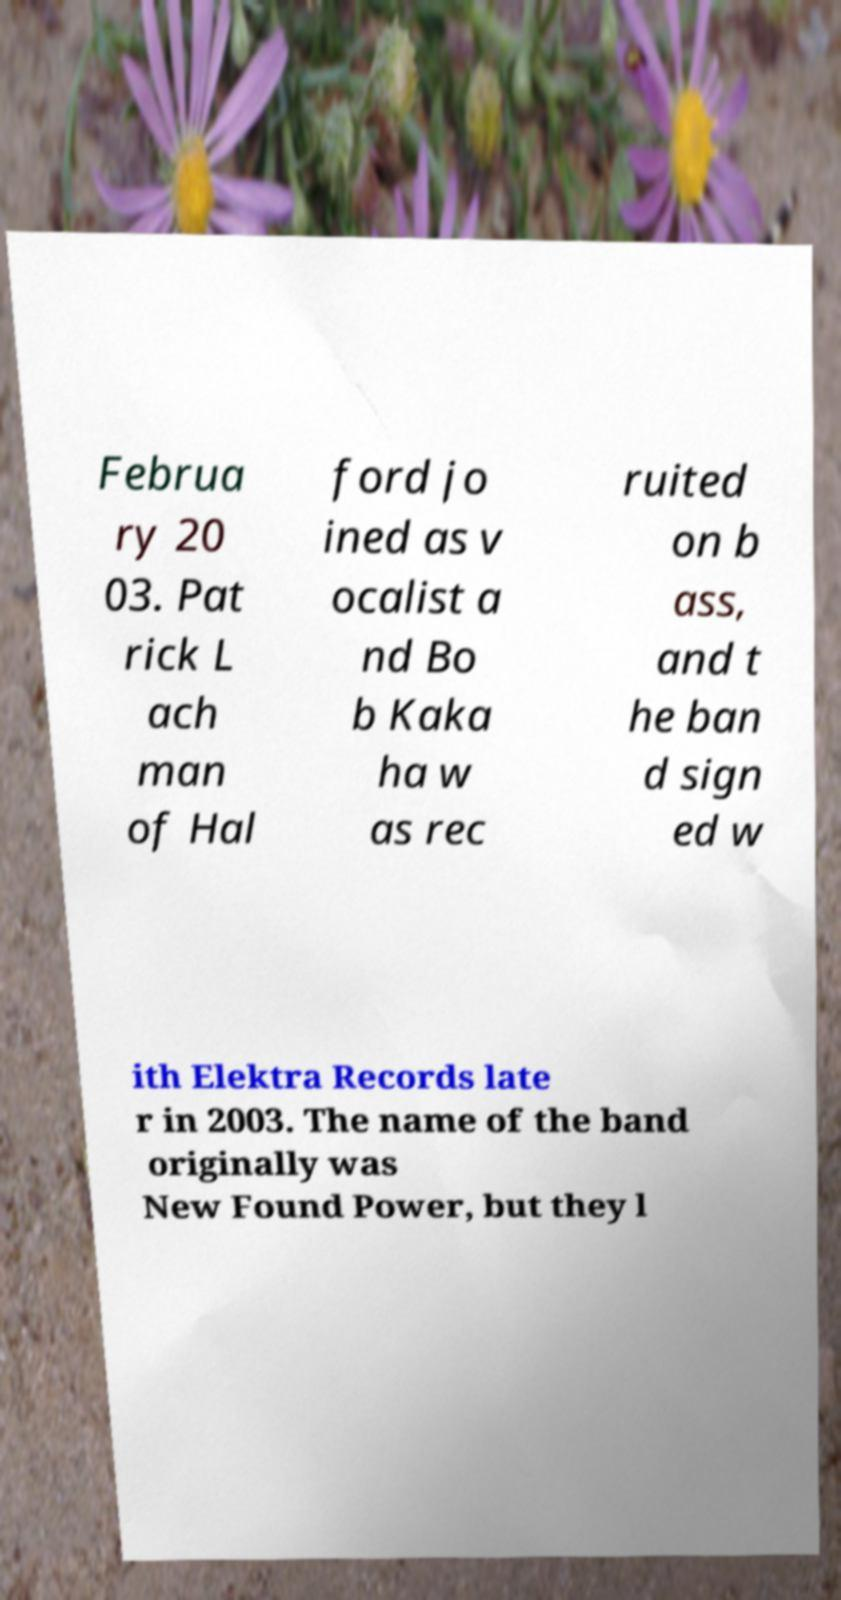Could you extract and type out the text from this image? Februa ry 20 03. Pat rick L ach man of Hal ford jo ined as v ocalist a nd Bo b Kaka ha w as rec ruited on b ass, and t he ban d sign ed w ith Elektra Records late r in 2003. The name of the band originally was New Found Power, but they l 